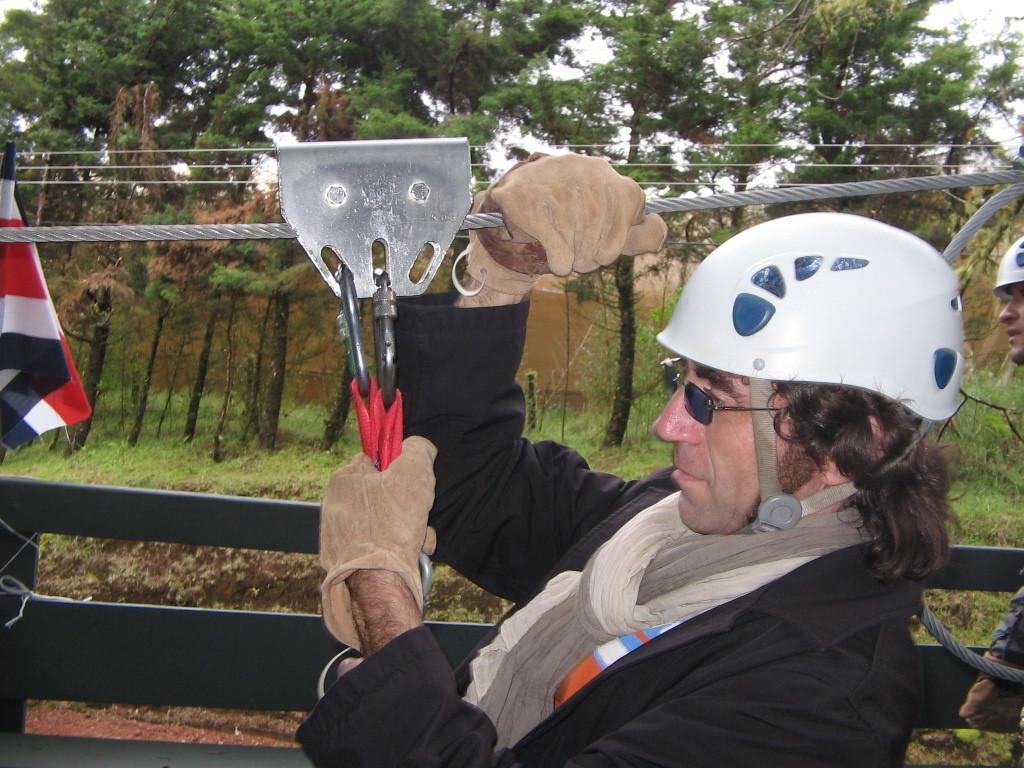How would you summarize this image in a sentence or two? In the center of the image there is a person wearing a black color jacket and white color helmet. He is holding a rope. In the background of the image there are trees. There is grass. To the left side of the image there is flag. 